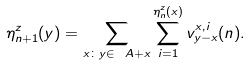<formula> <loc_0><loc_0><loc_500><loc_500>\eta _ { n + 1 } ^ { z } ( y ) = \sum _ { x \colon y \in \ A + x } \sum _ { i = 1 } ^ { \eta _ { n } ^ { z } ( x ) } v _ { y - x } ^ { x , i } ( n ) .</formula> 